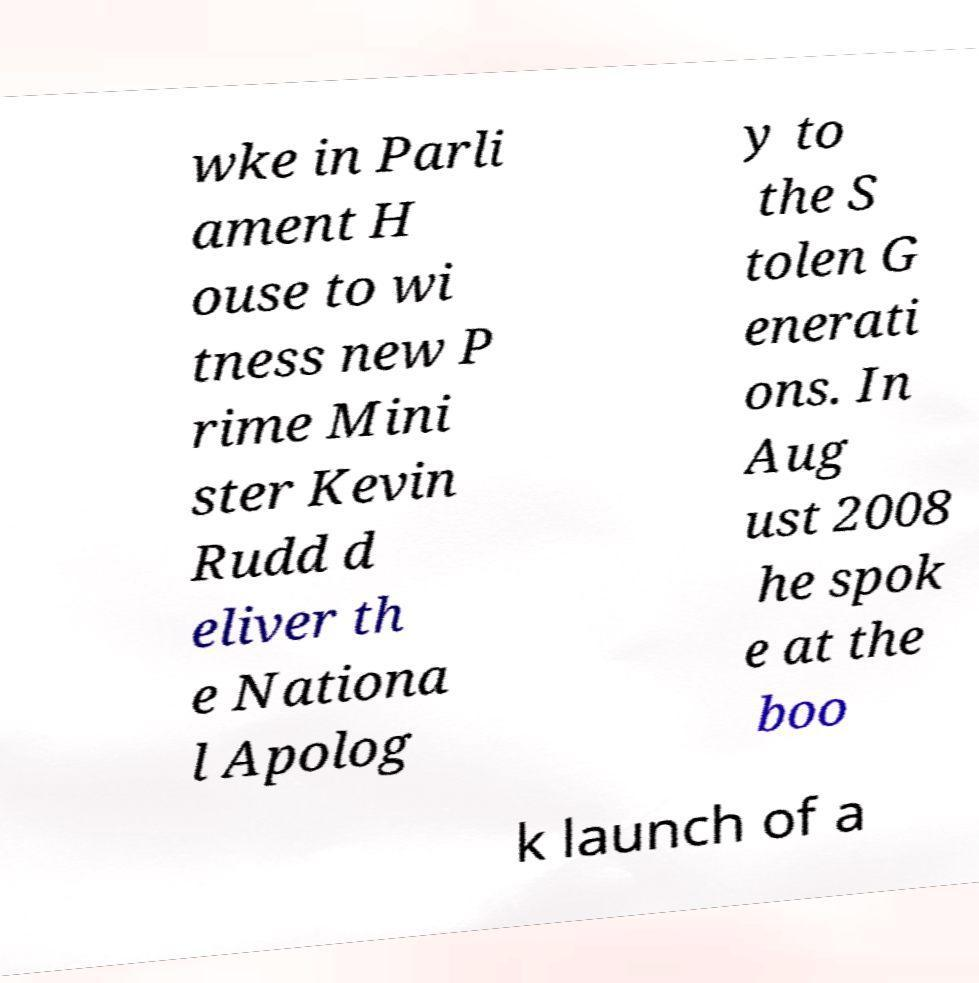For documentation purposes, I need the text within this image transcribed. Could you provide that? wke in Parli ament H ouse to wi tness new P rime Mini ster Kevin Rudd d eliver th e Nationa l Apolog y to the S tolen G enerati ons. In Aug ust 2008 he spok e at the boo k launch of a 